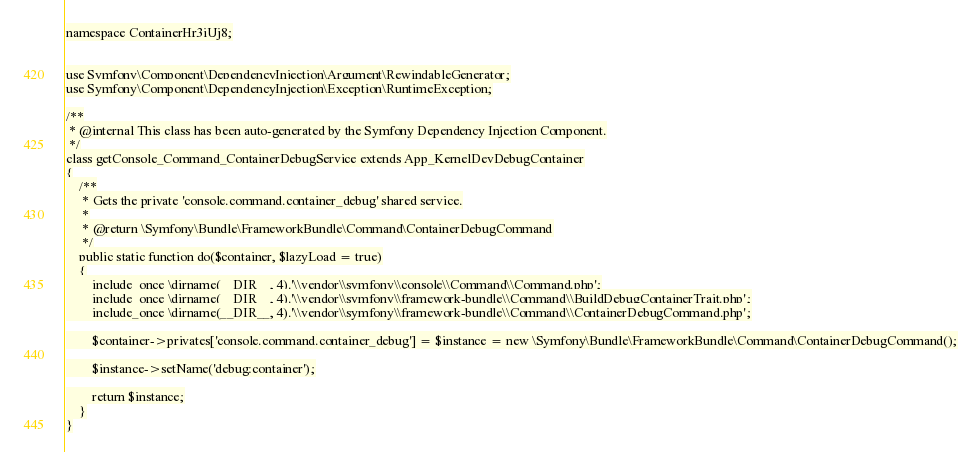Convert code to text. <code><loc_0><loc_0><loc_500><loc_500><_PHP_>
namespace ContainerHr3iUj8;


use Symfony\Component\DependencyInjection\Argument\RewindableGenerator;
use Symfony\Component\DependencyInjection\Exception\RuntimeException;

/**
 * @internal This class has been auto-generated by the Symfony Dependency Injection Component.
 */
class getConsole_Command_ContainerDebugService extends App_KernelDevDebugContainer
{
    /**
     * Gets the private 'console.command.container_debug' shared service.
     *
     * @return \Symfony\Bundle\FrameworkBundle\Command\ContainerDebugCommand
     */
    public static function do($container, $lazyLoad = true)
    {
        include_once \dirname(__DIR__, 4).'\\vendor\\symfony\\console\\Command\\Command.php';
        include_once \dirname(__DIR__, 4).'\\vendor\\symfony\\framework-bundle\\Command\\BuildDebugContainerTrait.php';
        include_once \dirname(__DIR__, 4).'\\vendor\\symfony\\framework-bundle\\Command\\ContainerDebugCommand.php';

        $container->privates['console.command.container_debug'] = $instance = new \Symfony\Bundle\FrameworkBundle\Command\ContainerDebugCommand();

        $instance->setName('debug:container');

        return $instance;
    }
}
</code> 